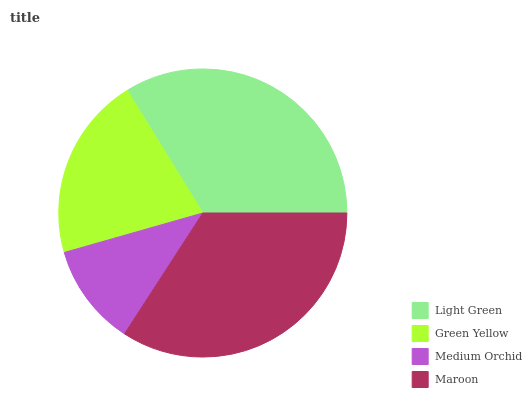Is Medium Orchid the minimum?
Answer yes or no. Yes. Is Maroon the maximum?
Answer yes or no. Yes. Is Green Yellow the minimum?
Answer yes or no. No. Is Green Yellow the maximum?
Answer yes or no. No. Is Light Green greater than Green Yellow?
Answer yes or no. Yes. Is Green Yellow less than Light Green?
Answer yes or no. Yes. Is Green Yellow greater than Light Green?
Answer yes or no. No. Is Light Green less than Green Yellow?
Answer yes or no. No. Is Light Green the high median?
Answer yes or no. Yes. Is Green Yellow the low median?
Answer yes or no. Yes. Is Medium Orchid the high median?
Answer yes or no. No. Is Light Green the low median?
Answer yes or no. No. 